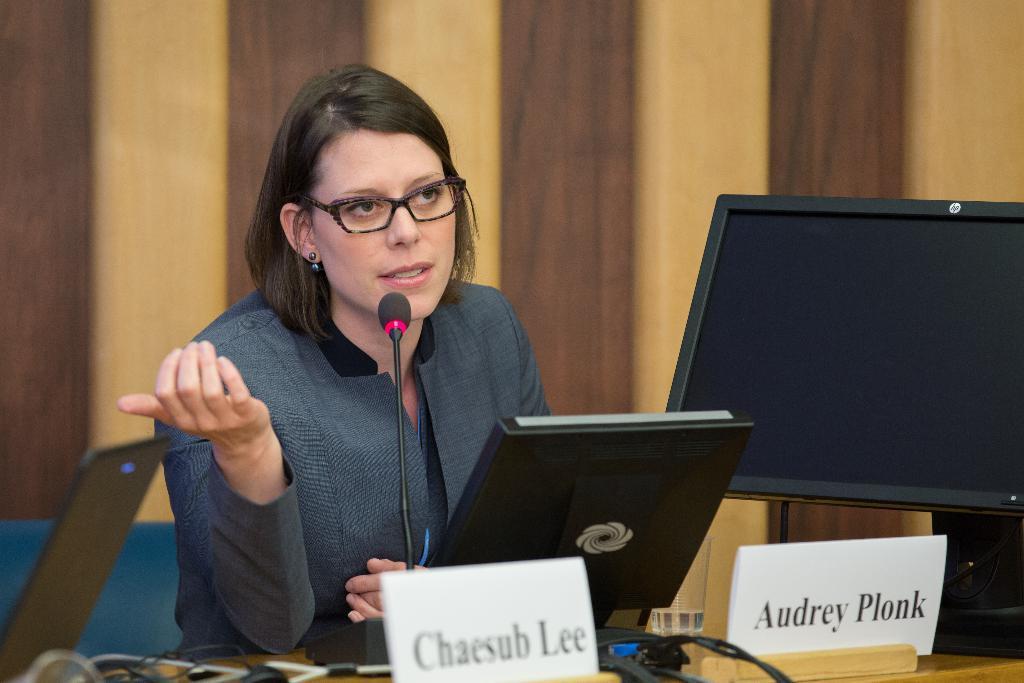In one or two sentences, can you explain what this image depicts? In this picture I can see a woman sitting and speaking with the help of a microphone on the table and I can see couple of monitors, name boards with some text on the table and I can see a wooden wall in the background and a chair on the left side of the picture. 